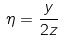<formula> <loc_0><loc_0><loc_500><loc_500>\eta = \frac { y } { 2 z }</formula> 